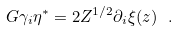Convert formula to latex. <formula><loc_0><loc_0><loc_500><loc_500>G \gamma _ { i } \eta ^ { * } = 2 Z ^ { 1 / 2 } \partial _ { i } \xi ( z ) \ .</formula> 